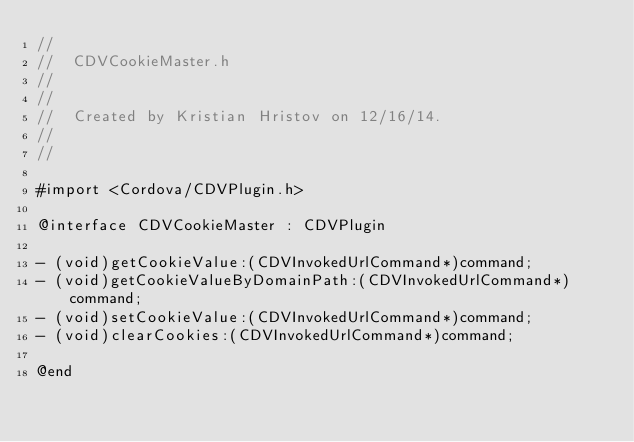Convert code to text. <code><loc_0><loc_0><loc_500><loc_500><_C_>//
//  CDVCookieMaster.h
//
//
//  Created by Kristian Hristov on 12/16/14.
//
//

#import <Cordova/CDVPlugin.h>

@interface CDVCookieMaster : CDVPlugin

- (void)getCookieValue:(CDVInvokedUrlCommand*)command;
- (void)getCookieValueByDomainPath:(CDVInvokedUrlCommand*)command;
- (void)setCookieValue:(CDVInvokedUrlCommand*)command;
- (void)clearCookies:(CDVInvokedUrlCommand*)command;

@end
</code> 